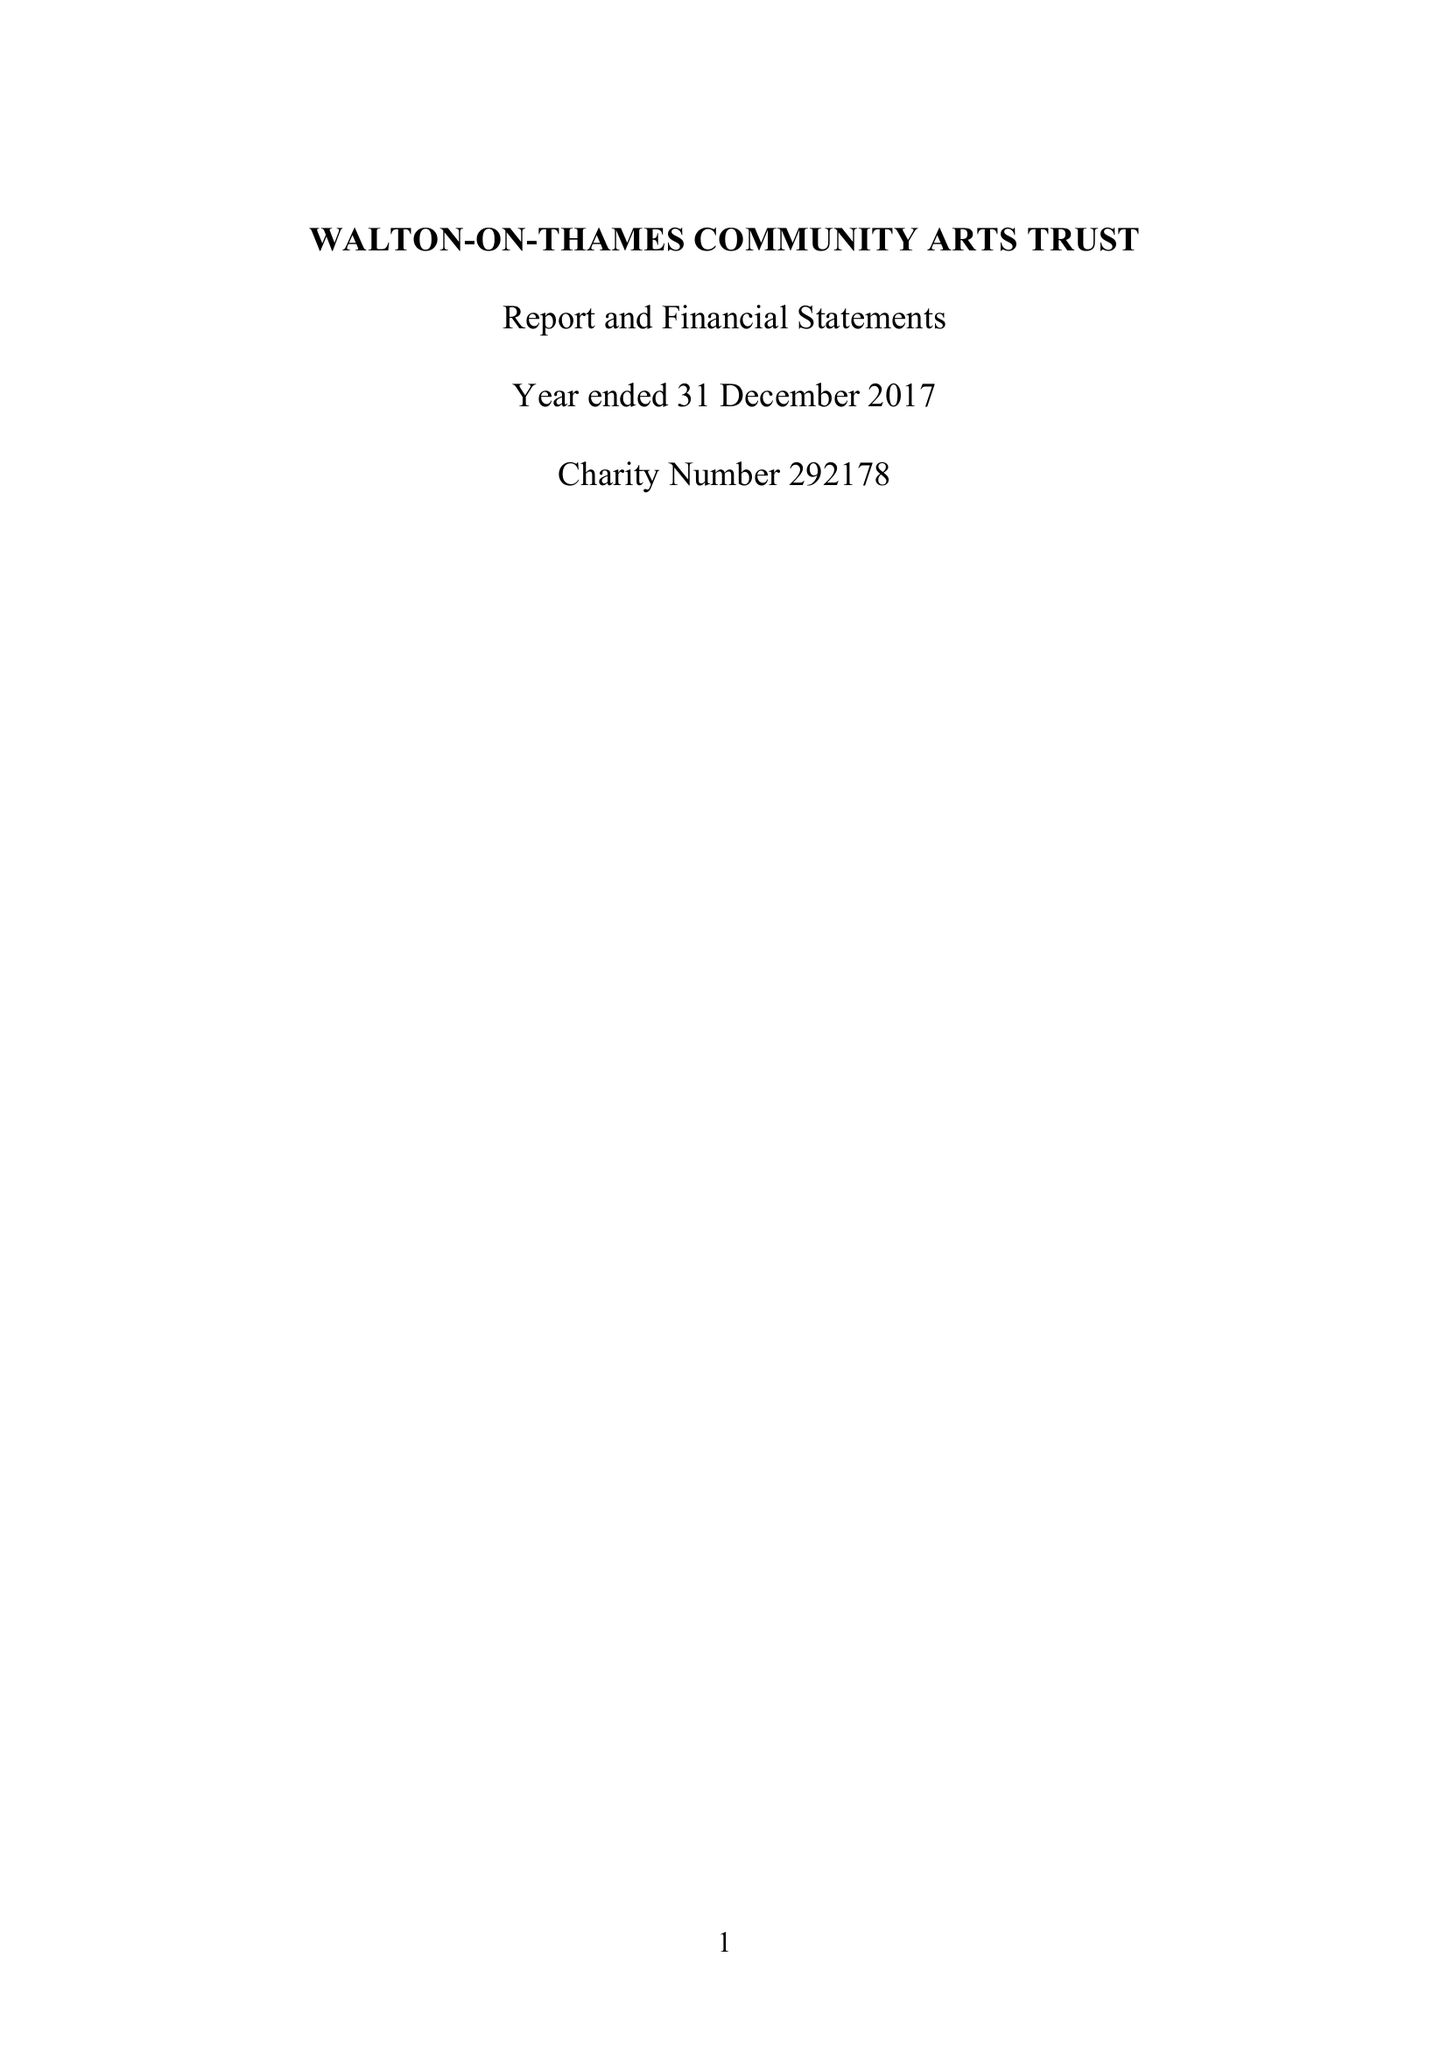What is the value for the address__postcode?
Answer the question using a single word or phrase. KT12 2PR 